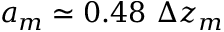<formula> <loc_0><loc_0><loc_500><loc_500>a _ { m } \simeq 0 . 4 8 \Delta z _ { m }</formula> 